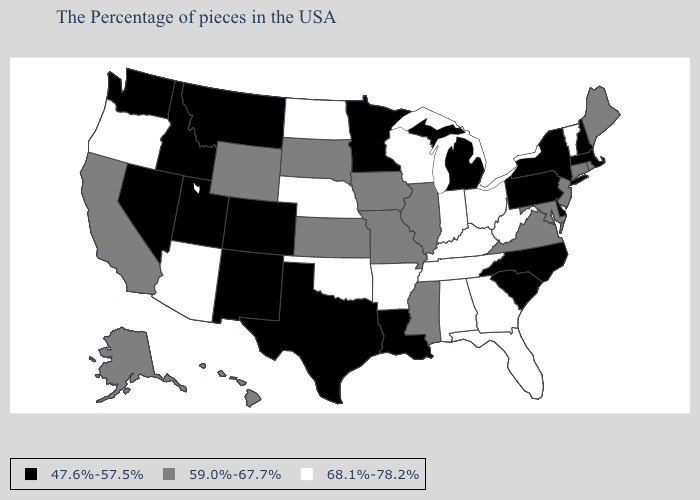What is the value of Hawaii?
Answer briefly. 59.0%-67.7%. What is the lowest value in the South?
Give a very brief answer. 47.6%-57.5%. Among the states that border Missouri , does Kansas have the lowest value?
Answer briefly. Yes. Is the legend a continuous bar?
Concise answer only. No. Does Tennessee have the highest value in the USA?
Concise answer only. Yes. What is the highest value in states that border Georgia?
Answer briefly. 68.1%-78.2%. Which states have the lowest value in the South?
Write a very short answer. Delaware, North Carolina, South Carolina, Louisiana, Texas. Does the map have missing data?
Answer briefly. No. Among the states that border Idaho , does Oregon have the highest value?
Be succinct. Yes. Which states have the lowest value in the USA?
Write a very short answer. Massachusetts, New Hampshire, New York, Delaware, Pennsylvania, North Carolina, South Carolina, Michigan, Louisiana, Minnesota, Texas, Colorado, New Mexico, Utah, Montana, Idaho, Nevada, Washington. Does Minnesota have the lowest value in the MidWest?
Short answer required. Yes. What is the value of Minnesota?
Answer briefly. 47.6%-57.5%. How many symbols are there in the legend?
Quick response, please. 3. Name the states that have a value in the range 47.6%-57.5%?
Answer briefly. Massachusetts, New Hampshire, New York, Delaware, Pennsylvania, North Carolina, South Carolina, Michigan, Louisiana, Minnesota, Texas, Colorado, New Mexico, Utah, Montana, Idaho, Nevada, Washington. Which states have the lowest value in the MidWest?
Answer briefly. Michigan, Minnesota. 